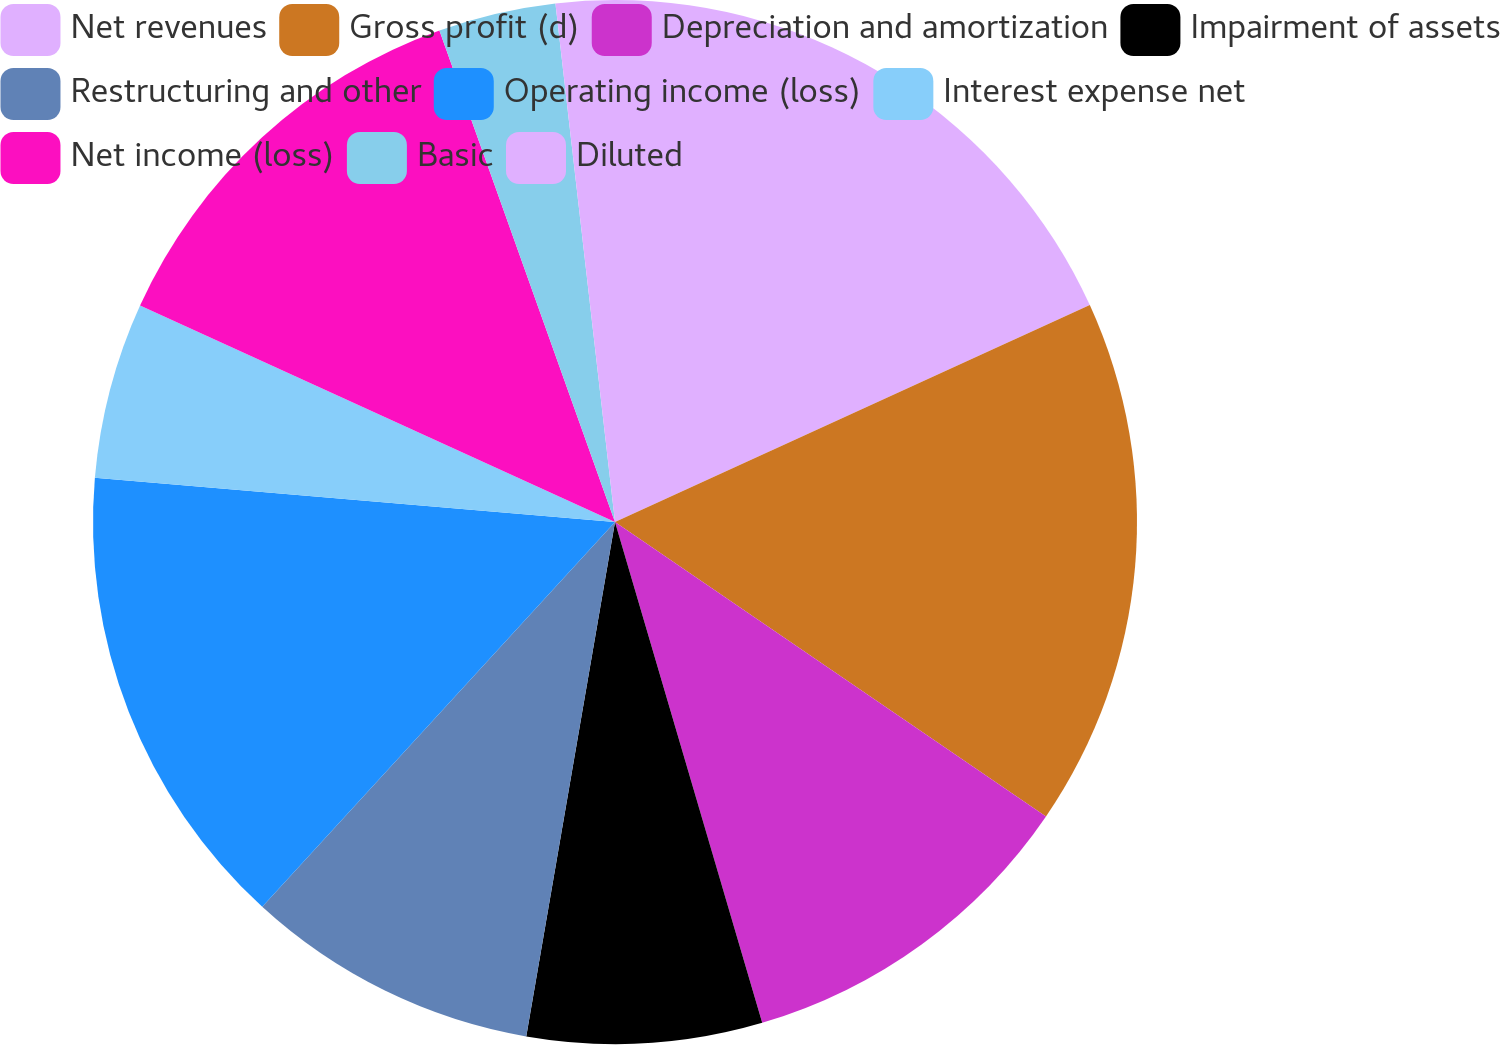Convert chart to OTSL. <chart><loc_0><loc_0><loc_500><loc_500><pie_chart><fcel>Net revenues<fcel>Gross profit (d)<fcel>Depreciation and amortization<fcel>Impairment of assets<fcel>Restructuring and other<fcel>Operating income (loss)<fcel>Interest expense net<fcel>Net income (loss)<fcel>Basic<fcel>Diluted<nl><fcel>18.18%<fcel>16.36%<fcel>10.91%<fcel>7.27%<fcel>9.09%<fcel>14.54%<fcel>5.46%<fcel>12.73%<fcel>3.64%<fcel>1.82%<nl></chart> 